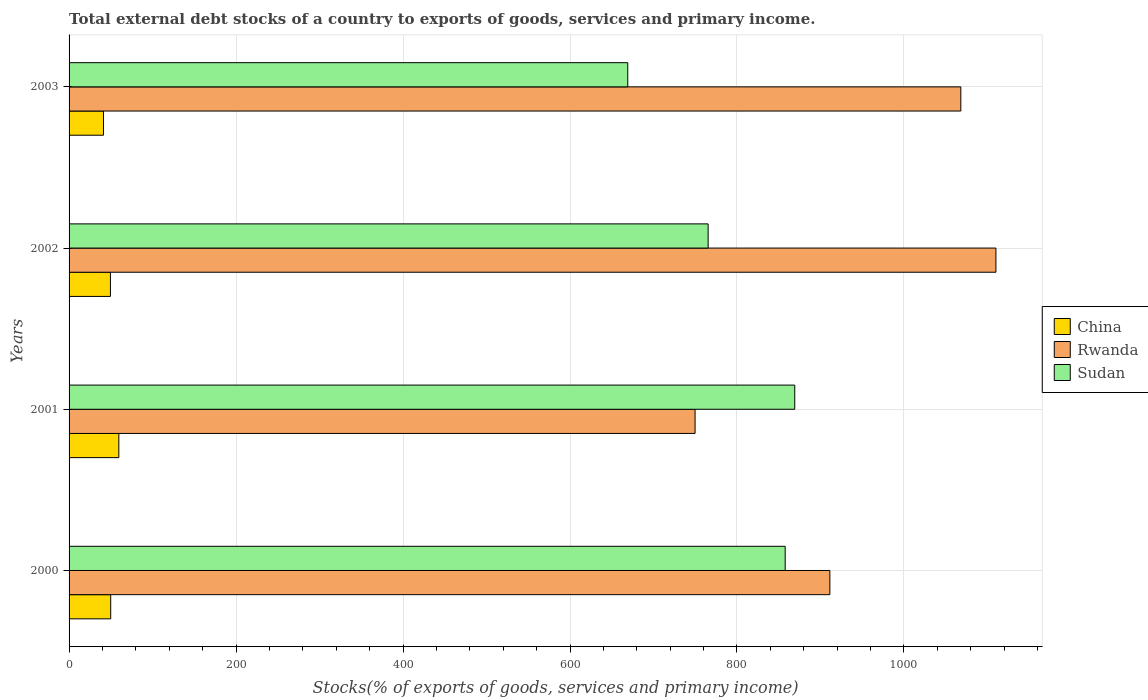How many different coloured bars are there?
Provide a succinct answer. 3. How many groups of bars are there?
Your answer should be very brief. 4. Are the number of bars on each tick of the Y-axis equal?
Your answer should be very brief. Yes. How many bars are there on the 2nd tick from the bottom?
Ensure brevity in your answer.  3. What is the total debt stocks in China in 2003?
Make the answer very short. 41.21. Across all years, what is the maximum total debt stocks in China?
Make the answer very short. 59.61. Across all years, what is the minimum total debt stocks in Rwanda?
Offer a terse response. 749.79. In which year was the total debt stocks in Rwanda maximum?
Offer a terse response. 2002. What is the total total debt stocks in China in the graph?
Your answer should be compact. 200.23. What is the difference between the total debt stocks in China in 2000 and that in 2002?
Your answer should be compact. 0.31. What is the difference between the total debt stocks in Sudan in 2000 and the total debt stocks in China in 2003?
Your answer should be very brief. 816.52. What is the average total debt stocks in China per year?
Keep it short and to the point. 50.06. In the year 2002, what is the difference between the total debt stocks in China and total debt stocks in Sudan?
Ensure brevity in your answer.  -715.87. What is the ratio of the total debt stocks in China in 2002 to that in 2003?
Ensure brevity in your answer.  1.2. Is the total debt stocks in China in 2000 less than that in 2003?
Your answer should be compact. No. Is the difference between the total debt stocks in China in 2001 and 2002 greater than the difference between the total debt stocks in Sudan in 2001 and 2002?
Offer a very short reply. No. What is the difference between the highest and the second highest total debt stocks in Sudan?
Provide a succinct answer. 11.45. What is the difference between the highest and the lowest total debt stocks in Sudan?
Ensure brevity in your answer.  200. What does the 1st bar from the top in 2001 represents?
Make the answer very short. Sudan. What does the 3rd bar from the bottom in 2000 represents?
Ensure brevity in your answer.  Sudan. How many bars are there?
Your answer should be very brief. 12. Are all the bars in the graph horizontal?
Offer a terse response. Yes. How many years are there in the graph?
Offer a terse response. 4. How many legend labels are there?
Offer a terse response. 3. What is the title of the graph?
Give a very brief answer. Total external debt stocks of a country to exports of goods, services and primary income. What is the label or title of the X-axis?
Your answer should be very brief. Stocks(% of exports of goods, services and primary income). What is the label or title of the Y-axis?
Offer a very short reply. Years. What is the Stocks(% of exports of goods, services and primary income) of China in 2000?
Give a very brief answer. 49.86. What is the Stocks(% of exports of goods, services and primary income) in Rwanda in 2000?
Your answer should be compact. 911.24. What is the Stocks(% of exports of goods, services and primary income) of Sudan in 2000?
Provide a short and direct response. 857.73. What is the Stocks(% of exports of goods, services and primary income) of China in 2001?
Give a very brief answer. 59.61. What is the Stocks(% of exports of goods, services and primary income) in Rwanda in 2001?
Make the answer very short. 749.79. What is the Stocks(% of exports of goods, services and primary income) in Sudan in 2001?
Your answer should be very brief. 869.18. What is the Stocks(% of exports of goods, services and primary income) in China in 2002?
Provide a short and direct response. 49.55. What is the Stocks(% of exports of goods, services and primary income) in Rwanda in 2002?
Offer a very short reply. 1110.12. What is the Stocks(% of exports of goods, services and primary income) of Sudan in 2002?
Provide a short and direct response. 765.42. What is the Stocks(% of exports of goods, services and primary income) in China in 2003?
Your answer should be very brief. 41.21. What is the Stocks(% of exports of goods, services and primary income) in Rwanda in 2003?
Your response must be concise. 1068.1. What is the Stocks(% of exports of goods, services and primary income) in Sudan in 2003?
Your answer should be compact. 669.18. Across all years, what is the maximum Stocks(% of exports of goods, services and primary income) in China?
Give a very brief answer. 59.61. Across all years, what is the maximum Stocks(% of exports of goods, services and primary income) of Rwanda?
Your answer should be compact. 1110.12. Across all years, what is the maximum Stocks(% of exports of goods, services and primary income) of Sudan?
Your answer should be very brief. 869.18. Across all years, what is the minimum Stocks(% of exports of goods, services and primary income) of China?
Your answer should be very brief. 41.21. Across all years, what is the minimum Stocks(% of exports of goods, services and primary income) in Rwanda?
Your answer should be compact. 749.79. Across all years, what is the minimum Stocks(% of exports of goods, services and primary income) in Sudan?
Your response must be concise. 669.18. What is the total Stocks(% of exports of goods, services and primary income) in China in the graph?
Keep it short and to the point. 200.23. What is the total Stocks(% of exports of goods, services and primary income) in Rwanda in the graph?
Keep it short and to the point. 3839.26. What is the total Stocks(% of exports of goods, services and primary income) of Sudan in the graph?
Provide a succinct answer. 3161.51. What is the difference between the Stocks(% of exports of goods, services and primary income) in China in 2000 and that in 2001?
Provide a short and direct response. -9.74. What is the difference between the Stocks(% of exports of goods, services and primary income) in Rwanda in 2000 and that in 2001?
Ensure brevity in your answer.  161.45. What is the difference between the Stocks(% of exports of goods, services and primary income) of Sudan in 2000 and that in 2001?
Provide a succinct answer. -11.45. What is the difference between the Stocks(% of exports of goods, services and primary income) in China in 2000 and that in 2002?
Ensure brevity in your answer.  0.31. What is the difference between the Stocks(% of exports of goods, services and primary income) in Rwanda in 2000 and that in 2002?
Give a very brief answer. -198.89. What is the difference between the Stocks(% of exports of goods, services and primary income) of Sudan in 2000 and that in 2002?
Give a very brief answer. 92.31. What is the difference between the Stocks(% of exports of goods, services and primary income) in China in 2000 and that in 2003?
Ensure brevity in your answer.  8.65. What is the difference between the Stocks(% of exports of goods, services and primary income) in Rwanda in 2000 and that in 2003?
Keep it short and to the point. -156.86. What is the difference between the Stocks(% of exports of goods, services and primary income) of Sudan in 2000 and that in 2003?
Offer a terse response. 188.56. What is the difference between the Stocks(% of exports of goods, services and primary income) of China in 2001 and that in 2002?
Give a very brief answer. 10.05. What is the difference between the Stocks(% of exports of goods, services and primary income) in Rwanda in 2001 and that in 2002?
Make the answer very short. -360.33. What is the difference between the Stocks(% of exports of goods, services and primary income) in Sudan in 2001 and that in 2002?
Ensure brevity in your answer.  103.76. What is the difference between the Stocks(% of exports of goods, services and primary income) of China in 2001 and that in 2003?
Provide a short and direct response. 18.39. What is the difference between the Stocks(% of exports of goods, services and primary income) of Rwanda in 2001 and that in 2003?
Keep it short and to the point. -318.31. What is the difference between the Stocks(% of exports of goods, services and primary income) in Sudan in 2001 and that in 2003?
Provide a succinct answer. 200. What is the difference between the Stocks(% of exports of goods, services and primary income) in China in 2002 and that in 2003?
Your response must be concise. 8.34. What is the difference between the Stocks(% of exports of goods, services and primary income) in Rwanda in 2002 and that in 2003?
Your answer should be very brief. 42.03. What is the difference between the Stocks(% of exports of goods, services and primary income) of Sudan in 2002 and that in 2003?
Provide a succinct answer. 96.25. What is the difference between the Stocks(% of exports of goods, services and primary income) in China in 2000 and the Stocks(% of exports of goods, services and primary income) in Rwanda in 2001?
Offer a terse response. -699.93. What is the difference between the Stocks(% of exports of goods, services and primary income) in China in 2000 and the Stocks(% of exports of goods, services and primary income) in Sudan in 2001?
Your answer should be compact. -819.32. What is the difference between the Stocks(% of exports of goods, services and primary income) in Rwanda in 2000 and the Stocks(% of exports of goods, services and primary income) in Sudan in 2001?
Keep it short and to the point. 42.06. What is the difference between the Stocks(% of exports of goods, services and primary income) in China in 2000 and the Stocks(% of exports of goods, services and primary income) in Rwanda in 2002?
Ensure brevity in your answer.  -1060.26. What is the difference between the Stocks(% of exports of goods, services and primary income) of China in 2000 and the Stocks(% of exports of goods, services and primary income) of Sudan in 2002?
Offer a terse response. -715.56. What is the difference between the Stocks(% of exports of goods, services and primary income) of Rwanda in 2000 and the Stocks(% of exports of goods, services and primary income) of Sudan in 2002?
Make the answer very short. 145.82. What is the difference between the Stocks(% of exports of goods, services and primary income) in China in 2000 and the Stocks(% of exports of goods, services and primary income) in Rwanda in 2003?
Your answer should be very brief. -1018.24. What is the difference between the Stocks(% of exports of goods, services and primary income) of China in 2000 and the Stocks(% of exports of goods, services and primary income) of Sudan in 2003?
Give a very brief answer. -619.31. What is the difference between the Stocks(% of exports of goods, services and primary income) of Rwanda in 2000 and the Stocks(% of exports of goods, services and primary income) of Sudan in 2003?
Provide a short and direct response. 242.06. What is the difference between the Stocks(% of exports of goods, services and primary income) of China in 2001 and the Stocks(% of exports of goods, services and primary income) of Rwanda in 2002?
Provide a short and direct response. -1050.52. What is the difference between the Stocks(% of exports of goods, services and primary income) of China in 2001 and the Stocks(% of exports of goods, services and primary income) of Sudan in 2002?
Ensure brevity in your answer.  -705.82. What is the difference between the Stocks(% of exports of goods, services and primary income) of Rwanda in 2001 and the Stocks(% of exports of goods, services and primary income) of Sudan in 2002?
Your response must be concise. -15.63. What is the difference between the Stocks(% of exports of goods, services and primary income) in China in 2001 and the Stocks(% of exports of goods, services and primary income) in Rwanda in 2003?
Your response must be concise. -1008.49. What is the difference between the Stocks(% of exports of goods, services and primary income) of China in 2001 and the Stocks(% of exports of goods, services and primary income) of Sudan in 2003?
Offer a very short reply. -609.57. What is the difference between the Stocks(% of exports of goods, services and primary income) in Rwanda in 2001 and the Stocks(% of exports of goods, services and primary income) in Sudan in 2003?
Provide a short and direct response. 80.62. What is the difference between the Stocks(% of exports of goods, services and primary income) in China in 2002 and the Stocks(% of exports of goods, services and primary income) in Rwanda in 2003?
Your answer should be compact. -1018.55. What is the difference between the Stocks(% of exports of goods, services and primary income) in China in 2002 and the Stocks(% of exports of goods, services and primary income) in Sudan in 2003?
Make the answer very short. -619.62. What is the difference between the Stocks(% of exports of goods, services and primary income) of Rwanda in 2002 and the Stocks(% of exports of goods, services and primary income) of Sudan in 2003?
Offer a terse response. 440.95. What is the average Stocks(% of exports of goods, services and primary income) of China per year?
Provide a succinct answer. 50.06. What is the average Stocks(% of exports of goods, services and primary income) in Rwanda per year?
Make the answer very short. 959.81. What is the average Stocks(% of exports of goods, services and primary income) of Sudan per year?
Your answer should be compact. 790.38. In the year 2000, what is the difference between the Stocks(% of exports of goods, services and primary income) in China and Stocks(% of exports of goods, services and primary income) in Rwanda?
Provide a short and direct response. -861.38. In the year 2000, what is the difference between the Stocks(% of exports of goods, services and primary income) of China and Stocks(% of exports of goods, services and primary income) of Sudan?
Your response must be concise. -807.87. In the year 2000, what is the difference between the Stocks(% of exports of goods, services and primary income) in Rwanda and Stocks(% of exports of goods, services and primary income) in Sudan?
Offer a very short reply. 53.51. In the year 2001, what is the difference between the Stocks(% of exports of goods, services and primary income) in China and Stocks(% of exports of goods, services and primary income) in Rwanda?
Your answer should be very brief. -690.19. In the year 2001, what is the difference between the Stocks(% of exports of goods, services and primary income) of China and Stocks(% of exports of goods, services and primary income) of Sudan?
Ensure brevity in your answer.  -809.57. In the year 2001, what is the difference between the Stocks(% of exports of goods, services and primary income) of Rwanda and Stocks(% of exports of goods, services and primary income) of Sudan?
Provide a short and direct response. -119.38. In the year 2002, what is the difference between the Stocks(% of exports of goods, services and primary income) in China and Stocks(% of exports of goods, services and primary income) in Rwanda?
Offer a terse response. -1060.57. In the year 2002, what is the difference between the Stocks(% of exports of goods, services and primary income) in China and Stocks(% of exports of goods, services and primary income) in Sudan?
Your answer should be very brief. -715.87. In the year 2002, what is the difference between the Stocks(% of exports of goods, services and primary income) of Rwanda and Stocks(% of exports of goods, services and primary income) of Sudan?
Offer a very short reply. 344.7. In the year 2003, what is the difference between the Stocks(% of exports of goods, services and primary income) of China and Stocks(% of exports of goods, services and primary income) of Rwanda?
Provide a succinct answer. -1026.88. In the year 2003, what is the difference between the Stocks(% of exports of goods, services and primary income) of China and Stocks(% of exports of goods, services and primary income) of Sudan?
Offer a very short reply. -627.96. In the year 2003, what is the difference between the Stocks(% of exports of goods, services and primary income) in Rwanda and Stocks(% of exports of goods, services and primary income) in Sudan?
Make the answer very short. 398.92. What is the ratio of the Stocks(% of exports of goods, services and primary income) of China in 2000 to that in 2001?
Provide a succinct answer. 0.84. What is the ratio of the Stocks(% of exports of goods, services and primary income) of Rwanda in 2000 to that in 2001?
Your answer should be compact. 1.22. What is the ratio of the Stocks(% of exports of goods, services and primary income) in Sudan in 2000 to that in 2001?
Your answer should be compact. 0.99. What is the ratio of the Stocks(% of exports of goods, services and primary income) of Rwanda in 2000 to that in 2002?
Offer a very short reply. 0.82. What is the ratio of the Stocks(% of exports of goods, services and primary income) in Sudan in 2000 to that in 2002?
Your answer should be compact. 1.12. What is the ratio of the Stocks(% of exports of goods, services and primary income) of China in 2000 to that in 2003?
Your answer should be very brief. 1.21. What is the ratio of the Stocks(% of exports of goods, services and primary income) of Rwanda in 2000 to that in 2003?
Ensure brevity in your answer.  0.85. What is the ratio of the Stocks(% of exports of goods, services and primary income) of Sudan in 2000 to that in 2003?
Ensure brevity in your answer.  1.28. What is the ratio of the Stocks(% of exports of goods, services and primary income) in China in 2001 to that in 2002?
Your answer should be very brief. 1.2. What is the ratio of the Stocks(% of exports of goods, services and primary income) of Rwanda in 2001 to that in 2002?
Make the answer very short. 0.68. What is the ratio of the Stocks(% of exports of goods, services and primary income) of Sudan in 2001 to that in 2002?
Your answer should be very brief. 1.14. What is the ratio of the Stocks(% of exports of goods, services and primary income) in China in 2001 to that in 2003?
Make the answer very short. 1.45. What is the ratio of the Stocks(% of exports of goods, services and primary income) of Rwanda in 2001 to that in 2003?
Your response must be concise. 0.7. What is the ratio of the Stocks(% of exports of goods, services and primary income) of Sudan in 2001 to that in 2003?
Offer a very short reply. 1.3. What is the ratio of the Stocks(% of exports of goods, services and primary income) of China in 2002 to that in 2003?
Offer a terse response. 1.2. What is the ratio of the Stocks(% of exports of goods, services and primary income) in Rwanda in 2002 to that in 2003?
Your answer should be very brief. 1.04. What is the ratio of the Stocks(% of exports of goods, services and primary income) in Sudan in 2002 to that in 2003?
Ensure brevity in your answer.  1.14. What is the difference between the highest and the second highest Stocks(% of exports of goods, services and primary income) in China?
Give a very brief answer. 9.74. What is the difference between the highest and the second highest Stocks(% of exports of goods, services and primary income) in Rwanda?
Offer a very short reply. 42.03. What is the difference between the highest and the second highest Stocks(% of exports of goods, services and primary income) of Sudan?
Offer a terse response. 11.45. What is the difference between the highest and the lowest Stocks(% of exports of goods, services and primary income) of China?
Your answer should be compact. 18.39. What is the difference between the highest and the lowest Stocks(% of exports of goods, services and primary income) of Rwanda?
Keep it short and to the point. 360.33. What is the difference between the highest and the lowest Stocks(% of exports of goods, services and primary income) of Sudan?
Your answer should be compact. 200. 